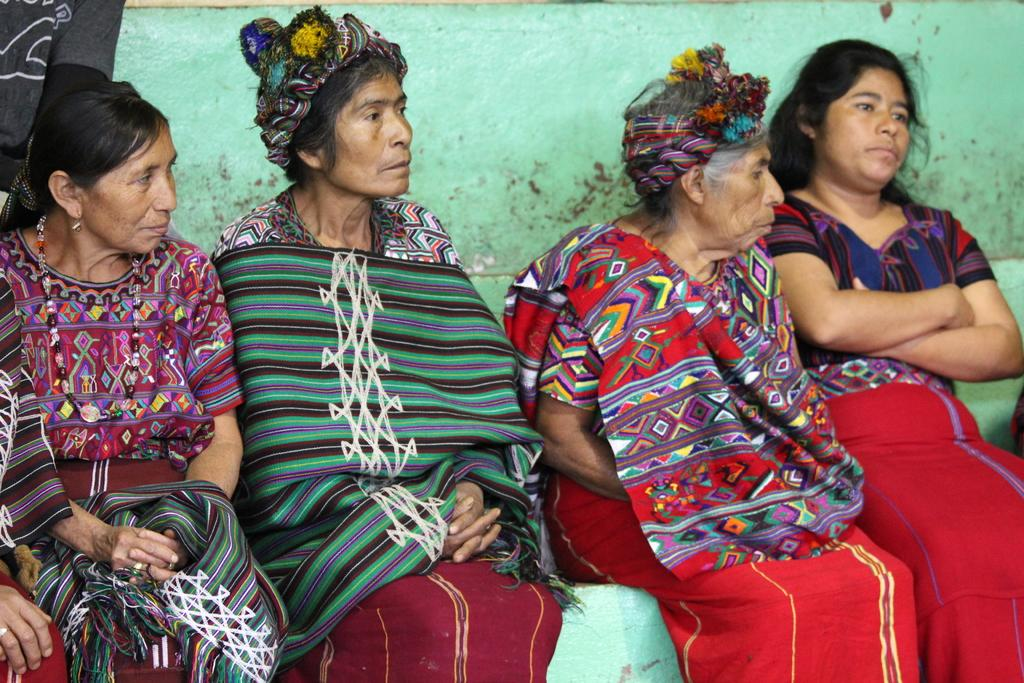What is the primary activity of the people in the image? There are women sitting in the image. What can be seen in the background behind the women? There is cloth and a wall visible in the background of the image. What type of steel structure can be seen in the image? There is no steel structure present in the image. What kind of dirt or soil is visible in the image? There is no dirt or soil visible in the image. 